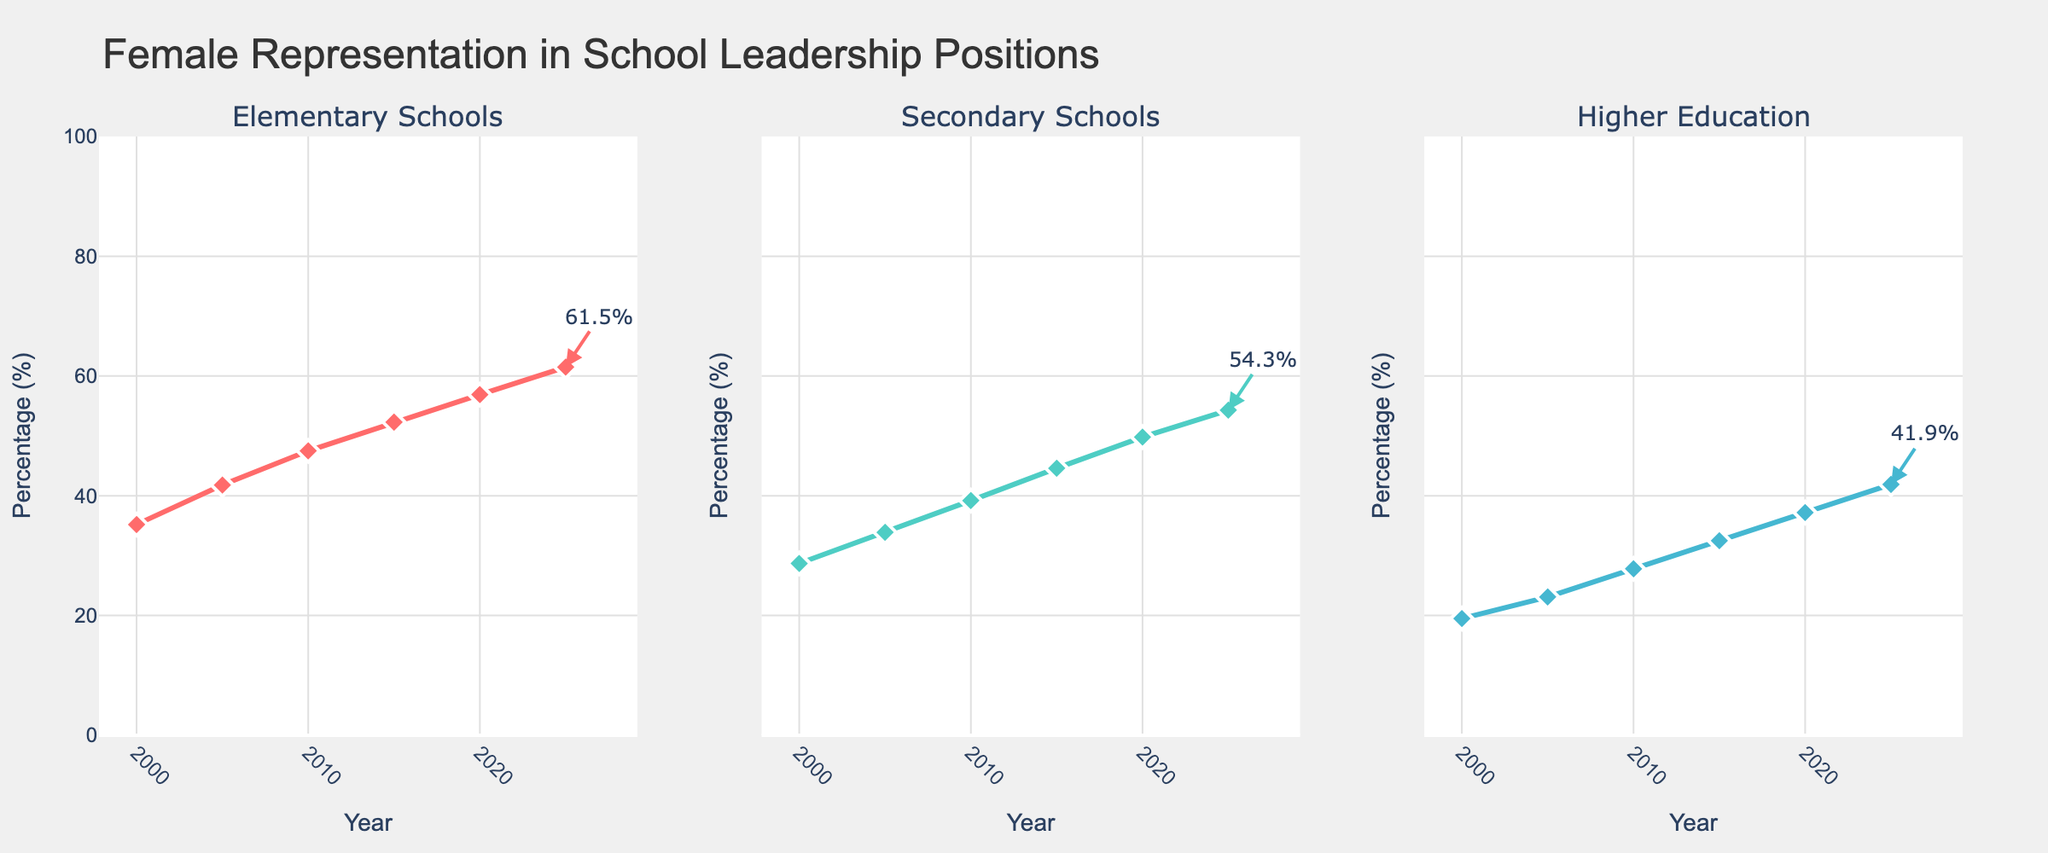What is the percentage of female representation in Elementary Schools in 2000? Look for the value at the point corresponding to the year 2000 in the subplot for Elementary Schools. The figure indicates that the percentage in 2000 is 35.2%.
Answer: 35.2% Which educational sector had the lowest female representation in 2020? Compare the data points for 2020 across all three subplots. Higher Education shows the lowest percentage, which is 37.2%.
Answer: Higher Education What is the overall trend in female representation in Secondary Schools from 2000 to 2025? Observe the line in the Secondary Schools subplot, which generally shows an upward trend from around 28.7% in 2000 to 54.3% in 2025.
Answer: Upward trend How many years did it take for the female representation in Elementary Schools to go from around 35% to over 50%? In the Elementary Schools subplot, female representation is at 35.2% in 2000 and crosses 50% by 2015. The difference is 2015 - 2000.
Answer: 15 years What is the difference in female representation between Elementary Schools and Higher Education in 2025? Look at the endpoints for both lines in 2025. Elementary Schools have 61.5%, and Higher Education has 41.9%. The difference is 61.5% - 41.9%.
Answer: 19.6% In which year did Secondary Schools see the most considerable increase in female representation compared to the previous year? Calculate the difference between consecutive years in the Secondary Schools subplot. The most significant increase happened between 2015 (44.6%) and 2020 (49.8%).
Answer: 2020 What is the percentage change in female representation in Higher Education from 2010 to 2025? Calculate the percentage change using the formula: ((final value - initial value) / initial value) * 100. For Higher Education, from 2010 (27.8%) to 2025 (41.9%): ((41.9 - 27.8) / 27.8) * 100.
Answer: 50.72% How does the female representation trend in Elementary Schools from 2000 to 2025 compare to that in Higher Education? Compare the slopes of the lines in both subplots. The Elementary Schools subplot shows a steeper, more consistent upward trend compared to Higher Education, which also trends upward but at a slower rate.
Answer: Steeper in Elementary Schools In 2020, by how many percentage points did Elementary Schools lead Secondary Schools in female representation? Find the difference between the percentages for Elementary Schools (56.9%) and Secondary Schools (49.8%) in 2020: 56.9% - 49.8%.
Answer: 7.1% What can you infer about gender representation efforts in School Leadership across all educational sectors over the given years? All three subplots show an upward trend, indicating increased female representation over the years, suggesting effective gender mainstreaming policies have been in place.
Answer: Increased female representation 